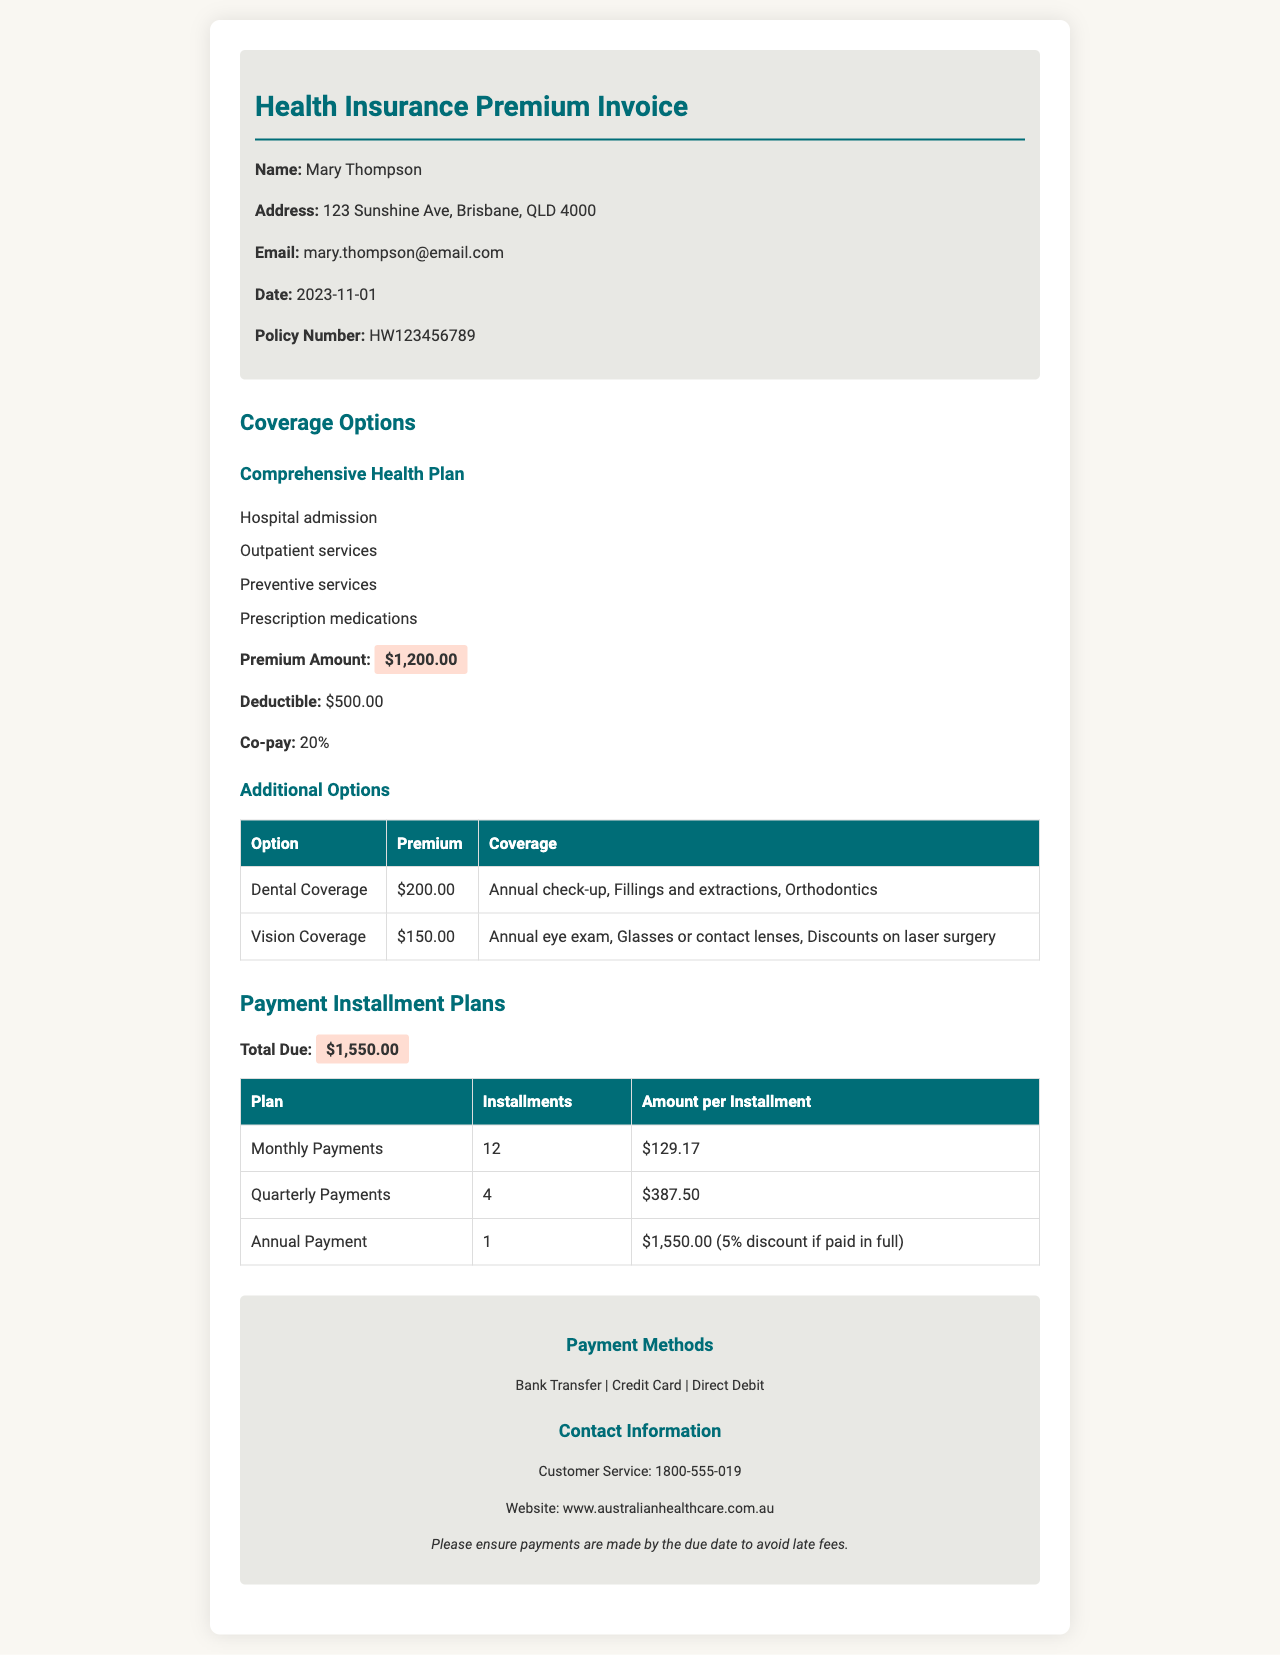what is the name of the policyholder? The name of the policyholder is provided at the top of the document.
Answer: Mary Thompson what is the premium amount for the Comprehensive Health Plan? This is listed under the coverage options section.
Answer: $1,200.00 what is the deductible for the health insurance plan? The deductible is mentioned in the coverage options section of the document.
Answer: $500.00 how many installments are there for monthly payments? The number of installments for monthly payments is detailed in the payment installment plans section.
Answer: 12 what is the total due for the health insurance invoice? This value is provided in the payment installment plans section.
Answer: $1,550.00 what is the coverage provided by the Dental Coverage option? The coverage details for the Dental option are listed in the additional options table.
Answer: Annual check-up, Fillings and extractions, Orthodontics how much is the amount per installment for Quarterly Payments? This amount is specified in the payment installment plans table.
Answer: $387.50 what is the customer service phone number? The contact information section provides this detail.
Answer: 1800-555-019 what discount is offered for annual payment? This information is provided in the payment installment plans section.
Answer: 5% discount if paid in full 